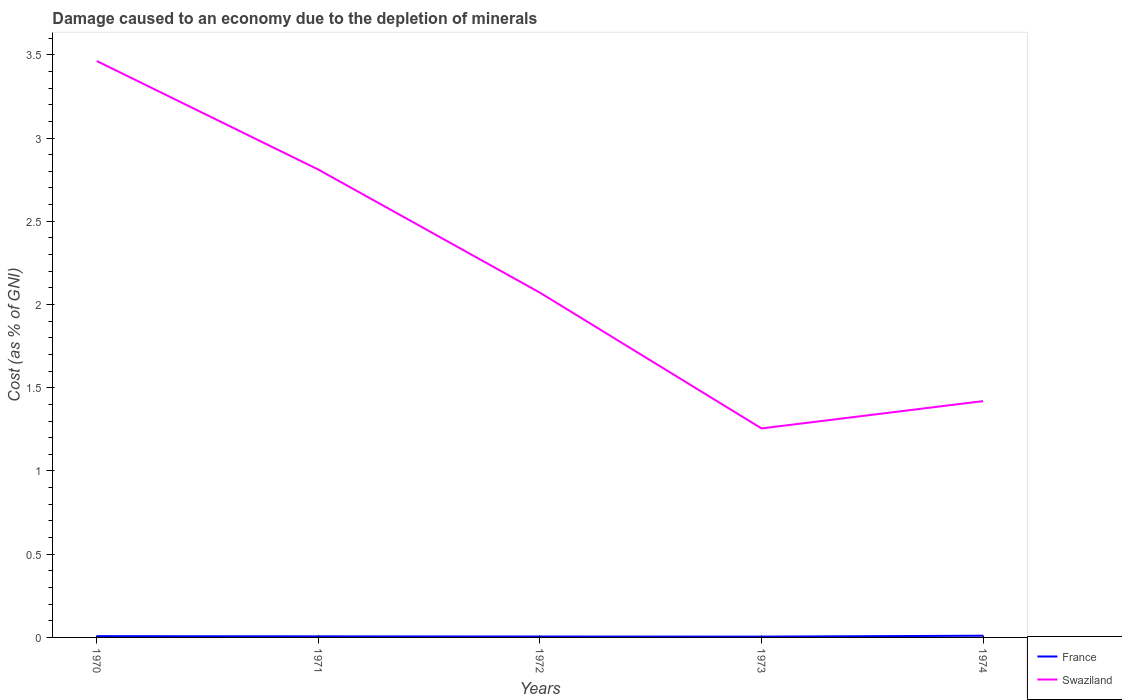How many different coloured lines are there?
Offer a very short reply. 2. Is the number of lines equal to the number of legend labels?
Offer a very short reply. Yes. Across all years, what is the maximum cost of damage caused due to the depletion of minerals in France?
Your response must be concise. 0. In which year was the cost of damage caused due to the depletion of minerals in France maximum?
Provide a succinct answer. 1973. What is the total cost of damage caused due to the depletion of minerals in France in the graph?
Your answer should be very brief. 0. What is the difference between the highest and the second highest cost of damage caused due to the depletion of minerals in France?
Your answer should be very brief. 0.01. How many years are there in the graph?
Ensure brevity in your answer.  5. Where does the legend appear in the graph?
Make the answer very short. Bottom right. What is the title of the graph?
Offer a very short reply. Damage caused to an economy due to the depletion of minerals. What is the label or title of the Y-axis?
Offer a very short reply. Cost (as % of GNI). What is the Cost (as % of GNI) of France in 1970?
Provide a short and direct response. 0.01. What is the Cost (as % of GNI) of Swaziland in 1970?
Your answer should be very brief. 3.46. What is the Cost (as % of GNI) in France in 1971?
Offer a very short reply. 0.01. What is the Cost (as % of GNI) of Swaziland in 1971?
Make the answer very short. 2.81. What is the Cost (as % of GNI) in France in 1972?
Give a very brief answer. 0.01. What is the Cost (as % of GNI) of Swaziland in 1972?
Your answer should be compact. 2.07. What is the Cost (as % of GNI) of France in 1973?
Give a very brief answer. 0. What is the Cost (as % of GNI) of Swaziland in 1973?
Offer a terse response. 1.26. What is the Cost (as % of GNI) of France in 1974?
Your response must be concise. 0.01. What is the Cost (as % of GNI) in Swaziland in 1974?
Provide a succinct answer. 1.42. Across all years, what is the maximum Cost (as % of GNI) of France?
Make the answer very short. 0.01. Across all years, what is the maximum Cost (as % of GNI) of Swaziland?
Offer a very short reply. 3.46. Across all years, what is the minimum Cost (as % of GNI) in France?
Make the answer very short. 0. Across all years, what is the minimum Cost (as % of GNI) of Swaziland?
Keep it short and to the point. 1.26. What is the total Cost (as % of GNI) in France in the graph?
Make the answer very short. 0.03. What is the total Cost (as % of GNI) in Swaziland in the graph?
Offer a very short reply. 11.02. What is the difference between the Cost (as % of GNI) in France in 1970 and that in 1971?
Your answer should be very brief. 0. What is the difference between the Cost (as % of GNI) of Swaziland in 1970 and that in 1971?
Ensure brevity in your answer.  0.65. What is the difference between the Cost (as % of GNI) of France in 1970 and that in 1972?
Ensure brevity in your answer.  0. What is the difference between the Cost (as % of GNI) of Swaziland in 1970 and that in 1972?
Your answer should be compact. 1.39. What is the difference between the Cost (as % of GNI) of France in 1970 and that in 1973?
Ensure brevity in your answer.  0. What is the difference between the Cost (as % of GNI) in Swaziland in 1970 and that in 1973?
Give a very brief answer. 2.21. What is the difference between the Cost (as % of GNI) in France in 1970 and that in 1974?
Make the answer very short. -0. What is the difference between the Cost (as % of GNI) in Swaziland in 1970 and that in 1974?
Offer a terse response. 2.04. What is the difference between the Cost (as % of GNI) of France in 1971 and that in 1972?
Provide a short and direct response. 0. What is the difference between the Cost (as % of GNI) in Swaziland in 1971 and that in 1972?
Your response must be concise. 0.74. What is the difference between the Cost (as % of GNI) in France in 1971 and that in 1973?
Provide a succinct answer. 0. What is the difference between the Cost (as % of GNI) in Swaziland in 1971 and that in 1973?
Make the answer very short. 1.55. What is the difference between the Cost (as % of GNI) in France in 1971 and that in 1974?
Give a very brief answer. -0. What is the difference between the Cost (as % of GNI) of Swaziland in 1971 and that in 1974?
Offer a terse response. 1.39. What is the difference between the Cost (as % of GNI) of France in 1972 and that in 1973?
Provide a short and direct response. 0. What is the difference between the Cost (as % of GNI) of Swaziland in 1972 and that in 1973?
Offer a terse response. 0.82. What is the difference between the Cost (as % of GNI) in France in 1972 and that in 1974?
Keep it short and to the point. -0. What is the difference between the Cost (as % of GNI) in Swaziland in 1972 and that in 1974?
Your response must be concise. 0.65. What is the difference between the Cost (as % of GNI) of France in 1973 and that in 1974?
Provide a succinct answer. -0.01. What is the difference between the Cost (as % of GNI) in Swaziland in 1973 and that in 1974?
Your answer should be compact. -0.16. What is the difference between the Cost (as % of GNI) in France in 1970 and the Cost (as % of GNI) in Swaziland in 1971?
Keep it short and to the point. -2.8. What is the difference between the Cost (as % of GNI) in France in 1970 and the Cost (as % of GNI) in Swaziland in 1972?
Offer a very short reply. -2.06. What is the difference between the Cost (as % of GNI) of France in 1970 and the Cost (as % of GNI) of Swaziland in 1973?
Ensure brevity in your answer.  -1.25. What is the difference between the Cost (as % of GNI) of France in 1970 and the Cost (as % of GNI) of Swaziland in 1974?
Your answer should be compact. -1.41. What is the difference between the Cost (as % of GNI) in France in 1971 and the Cost (as % of GNI) in Swaziland in 1972?
Your response must be concise. -2.06. What is the difference between the Cost (as % of GNI) of France in 1971 and the Cost (as % of GNI) of Swaziland in 1973?
Provide a succinct answer. -1.25. What is the difference between the Cost (as % of GNI) of France in 1971 and the Cost (as % of GNI) of Swaziland in 1974?
Make the answer very short. -1.41. What is the difference between the Cost (as % of GNI) in France in 1972 and the Cost (as % of GNI) in Swaziland in 1973?
Keep it short and to the point. -1.25. What is the difference between the Cost (as % of GNI) in France in 1972 and the Cost (as % of GNI) in Swaziland in 1974?
Your answer should be very brief. -1.41. What is the difference between the Cost (as % of GNI) of France in 1973 and the Cost (as % of GNI) of Swaziland in 1974?
Give a very brief answer. -1.41. What is the average Cost (as % of GNI) in France per year?
Ensure brevity in your answer.  0.01. What is the average Cost (as % of GNI) of Swaziland per year?
Make the answer very short. 2.2. In the year 1970, what is the difference between the Cost (as % of GNI) in France and Cost (as % of GNI) in Swaziland?
Provide a succinct answer. -3.45. In the year 1971, what is the difference between the Cost (as % of GNI) of France and Cost (as % of GNI) of Swaziland?
Your response must be concise. -2.8. In the year 1972, what is the difference between the Cost (as % of GNI) in France and Cost (as % of GNI) in Swaziland?
Provide a succinct answer. -2.07. In the year 1973, what is the difference between the Cost (as % of GNI) of France and Cost (as % of GNI) of Swaziland?
Offer a very short reply. -1.25. In the year 1974, what is the difference between the Cost (as % of GNI) of France and Cost (as % of GNI) of Swaziland?
Your response must be concise. -1.41. What is the ratio of the Cost (as % of GNI) in France in 1970 to that in 1971?
Your answer should be compact. 1.19. What is the ratio of the Cost (as % of GNI) of Swaziland in 1970 to that in 1971?
Your answer should be very brief. 1.23. What is the ratio of the Cost (as % of GNI) in France in 1970 to that in 1972?
Provide a short and direct response. 1.42. What is the ratio of the Cost (as % of GNI) of Swaziland in 1970 to that in 1972?
Offer a terse response. 1.67. What is the ratio of the Cost (as % of GNI) of France in 1970 to that in 1973?
Your response must be concise. 1.59. What is the ratio of the Cost (as % of GNI) in Swaziland in 1970 to that in 1973?
Offer a terse response. 2.76. What is the ratio of the Cost (as % of GNI) of France in 1970 to that in 1974?
Ensure brevity in your answer.  0.75. What is the ratio of the Cost (as % of GNI) of Swaziland in 1970 to that in 1974?
Offer a terse response. 2.44. What is the ratio of the Cost (as % of GNI) in France in 1971 to that in 1972?
Your response must be concise. 1.19. What is the ratio of the Cost (as % of GNI) in Swaziland in 1971 to that in 1972?
Your answer should be compact. 1.36. What is the ratio of the Cost (as % of GNI) in France in 1971 to that in 1973?
Provide a short and direct response. 1.33. What is the ratio of the Cost (as % of GNI) of Swaziland in 1971 to that in 1973?
Offer a very short reply. 2.24. What is the ratio of the Cost (as % of GNI) of France in 1971 to that in 1974?
Offer a very short reply. 0.63. What is the ratio of the Cost (as % of GNI) in Swaziland in 1971 to that in 1974?
Your answer should be compact. 1.98. What is the ratio of the Cost (as % of GNI) of France in 1972 to that in 1973?
Provide a short and direct response. 1.12. What is the ratio of the Cost (as % of GNI) of Swaziland in 1972 to that in 1973?
Keep it short and to the point. 1.65. What is the ratio of the Cost (as % of GNI) of France in 1972 to that in 1974?
Ensure brevity in your answer.  0.53. What is the ratio of the Cost (as % of GNI) in Swaziland in 1972 to that in 1974?
Ensure brevity in your answer.  1.46. What is the ratio of the Cost (as % of GNI) in France in 1973 to that in 1974?
Provide a succinct answer. 0.47. What is the ratio of the Cost (as % of GNI) in Swaziland in 1973 to that in 1974?
Provide a short and direct response. 0.88. What is the difference between the highest and the second highest Cost (as % of GNI) in France?
Provide a succinct answer. 0. What is the difference between the highest and the second highest Cost (as % of GNI) of Swaziland?
Provide a short and direct response. 0.65. What is the difference between the highest and the lowest Cost (as % of GNI) of France?
Your answer should be compact. 0.01. What is the difference between the highest and the lowest Cost (as % of GNI) of Swaziland?
Keep it short and to the point. 2.21. 